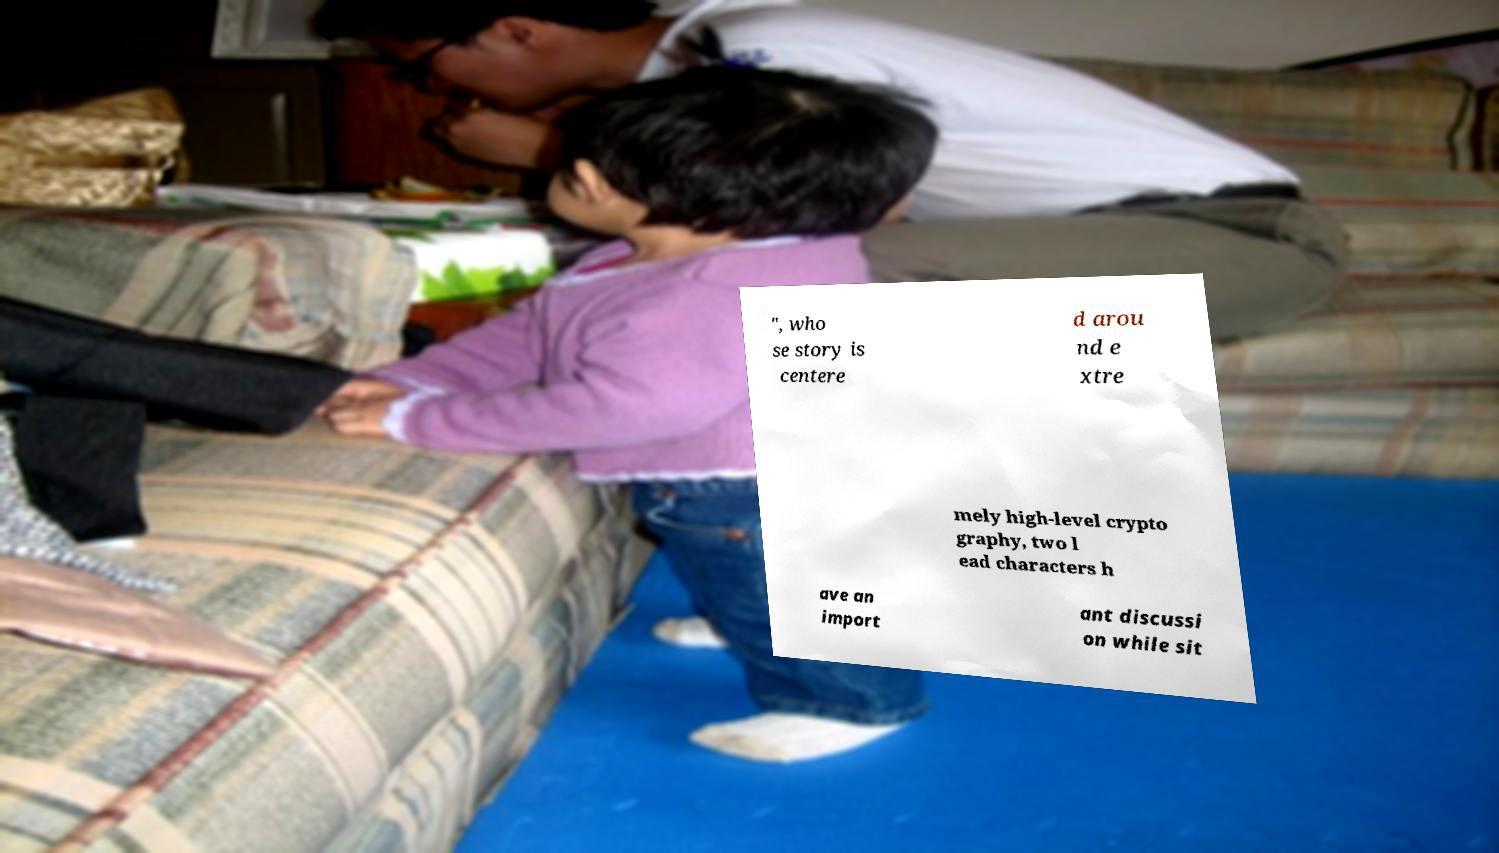What messages or text are displayed in this image? I need them in a readable, typed format. ", who se story is centere d arou nd e xtre mely high-level crypto graphy, two l ead characters h ave an import ant discussi on while sit 